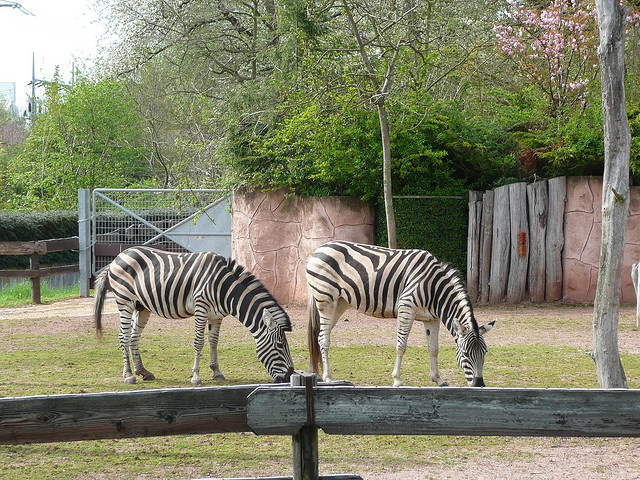Describe the objects in this image and their specific colors. I can see zebra in lightgray, gray, black, darkgray, and ivory tones and zebra in lavender, darkgray, gray, ivory, and black tones in this image. 